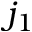<formula> <loc_0><loc_0><loc_500><loc_500>j _ { 1 }</formula> 